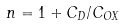<formula> <loc_0><loc_0><loc_500><loc_500>n = 1 + C _ { D } / C _ { O X }</formula> 